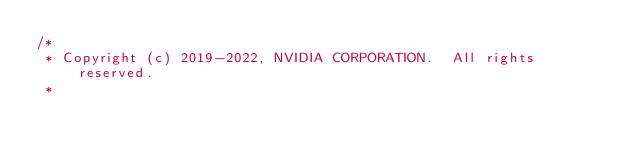<code> <loc_0><loc_0><loc_500><loc_500><_Cuda_>/*
 * Copyright (c) 2019-2022, NVIDIA CORPORATION.  All rights reserved.
 *</code> 